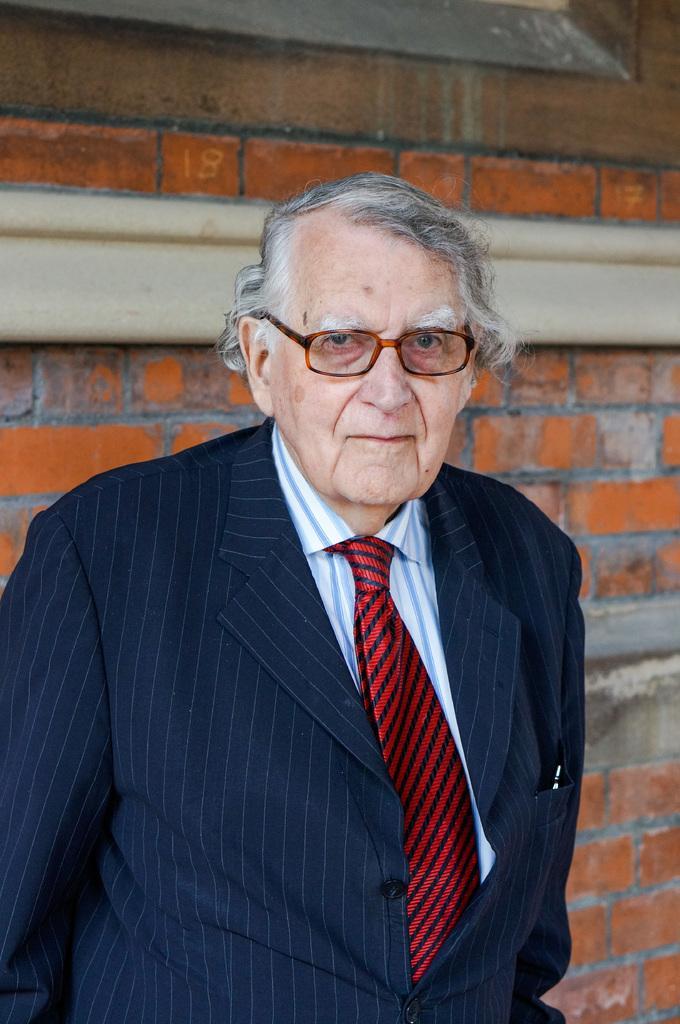Describe this image in one or two sentences. In this image there is a man standing, in the background there is wall. 